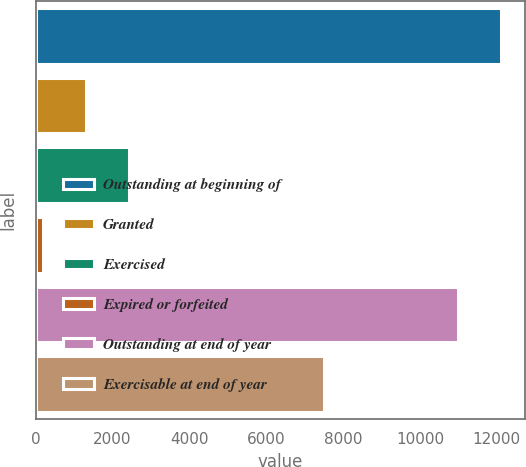Convert chart to OTSL. <chart><loc_0><loc_0><loc_500><loc_500><bar_chart><fcel>Outstanding at beginning of<fcel>Granted<fcel>Exercised<fcel>Expired or forfeited<fcel>Outstanding at end of year<fcel>Exercisable at end of year<nl><fcel>12123.1<fcel>1320.1<fcel>2439.2<fcel>201<fcel>11004<fcel>7494<nl></chart> 